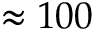Convert formula to latex. <formula><loc_0><loc_0><loc_500><loc_500>\approx 1 0 0</formula> 